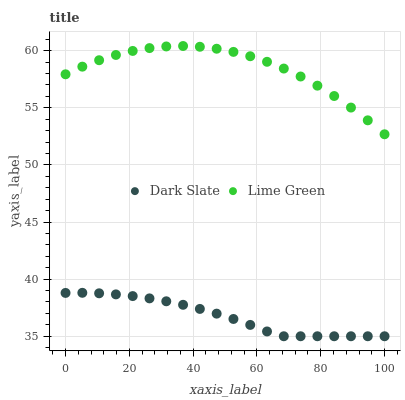Does Dark Slate have the minimum area under the curve?
Answer yes or no. Yes. Does Lime Green have the maximum area under the curve?
Answer yes or no. Yes. Does Lime Green have the minimum area under the curve?
Answer yes or no. No. Is Dark Slate the smoothest?
Answer yes or no. Yes. Is Lime Green the roughest?
Answer yes or no. Yes. Is Lime Green the smoothest?
Answer yes or no. No. Does Dark Slate have the lowest value?
Answer yes or no. Yes. Does Lime Green have the lowest value?
Answer yes or no. No. Does Lime Green have the highest value?
Answer yes or no. Yes. Is Dark Slate less than Lime Green?
Answer yes or no. Yes. Is Lime Green greater than Dark Slate?
Answer yes or no. Yes. Does Dark Slate intersect Lime Green?
Answer yes or no. No. 